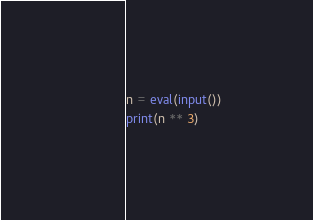<code> <loc_0><loc_0><loc_500><loc_500><_Python_>n = eval(input())
print(n ** 3)
</code> 